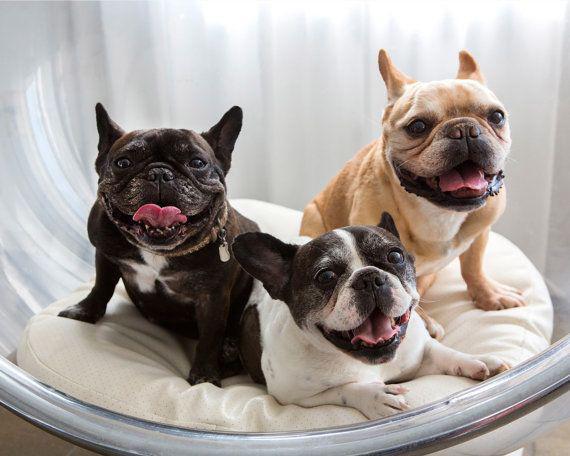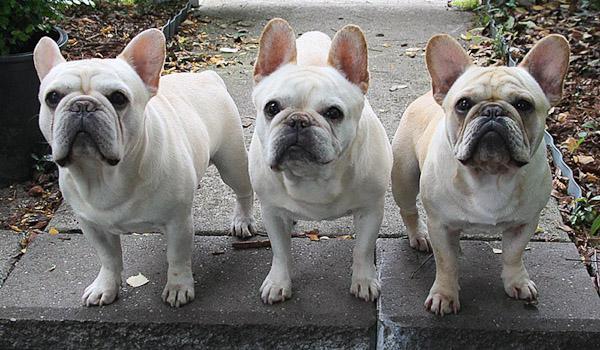The first image is the image on the left, the second image is the image on the right. Given the left and right images, does the statement "In one of the images, the dogs are standing on the pavement outside." hold true? Answer yes or no. Yes. The first image is the image on the left, the second image is the image on the right. Considering the images on both sides, is "An image shows a horizontal row of three similarly colored dogs in similar poses." valid? Answer yes or no. Yes. 